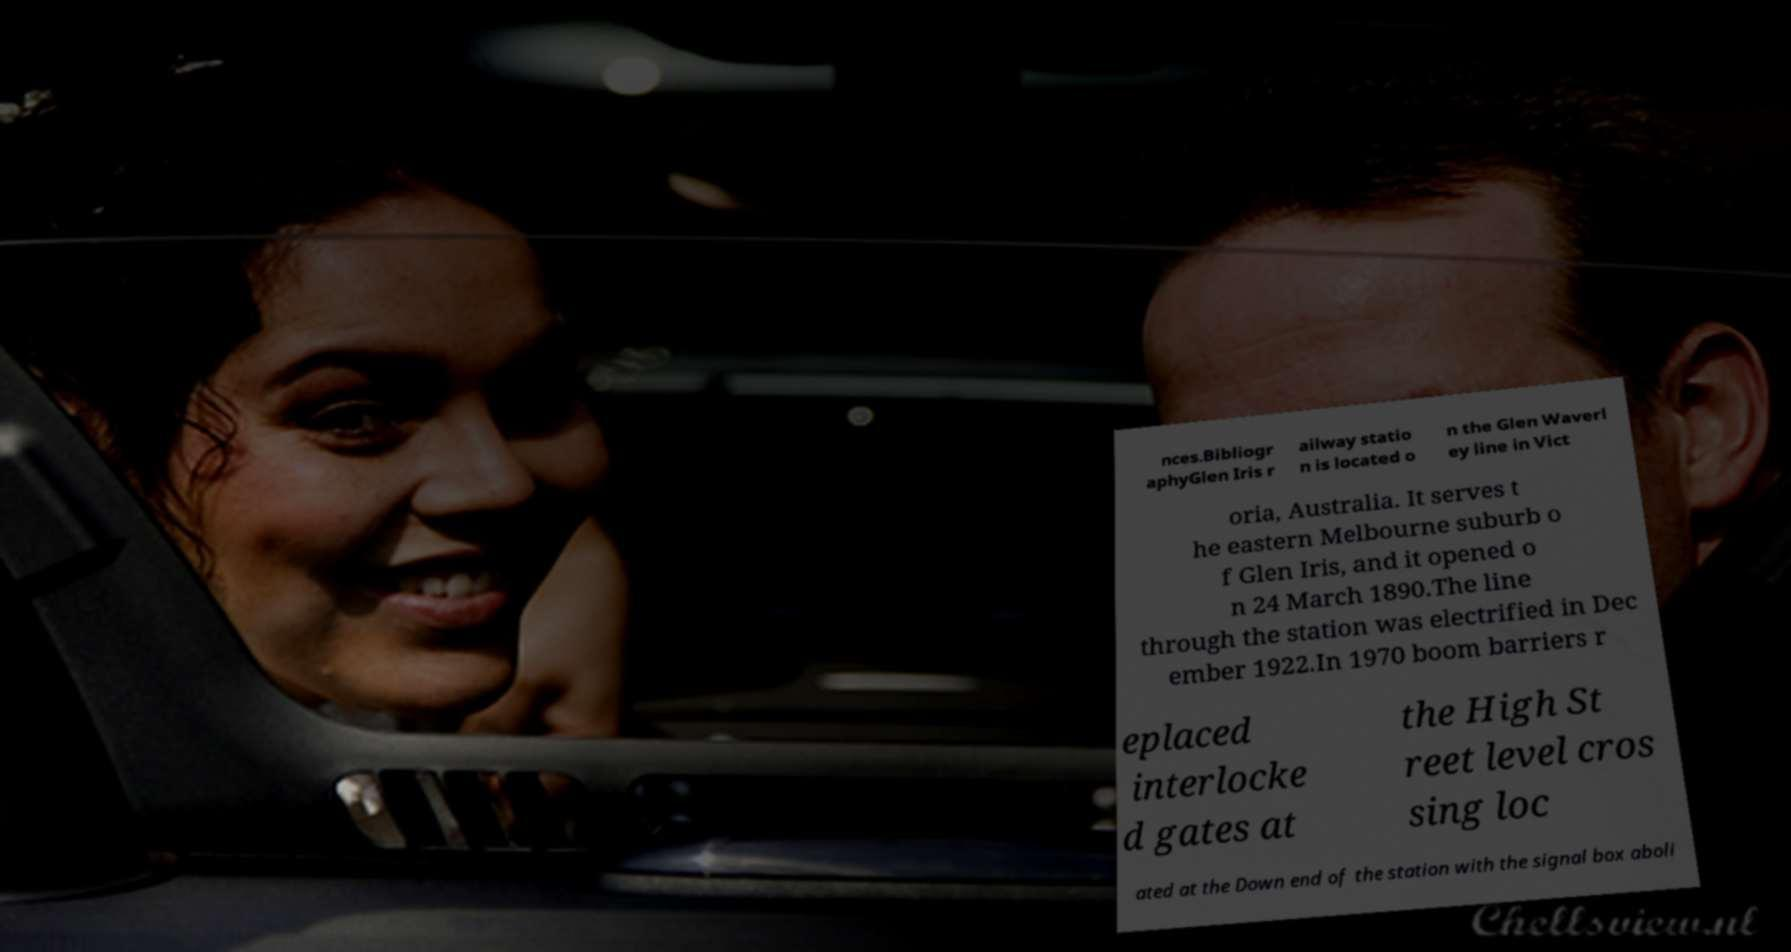For documentation purposes, I need the text within this image transcribed. Could you provide that? nces.Bibliogr aphyGlen Iris r ailway statio n is located o n the Glen Waverl ey line in Vict oria, Australia. It serves t he eastern Melbourne suburb o f Glen Iris, and it opened o n 24 March 1890.The line through the station was electrified in Dec ember 1922.In 1970 boom barriers r eplaced interlocke d gates at the High St reet level cros sing loc ated at the Down end of the station with the signal box aboli 